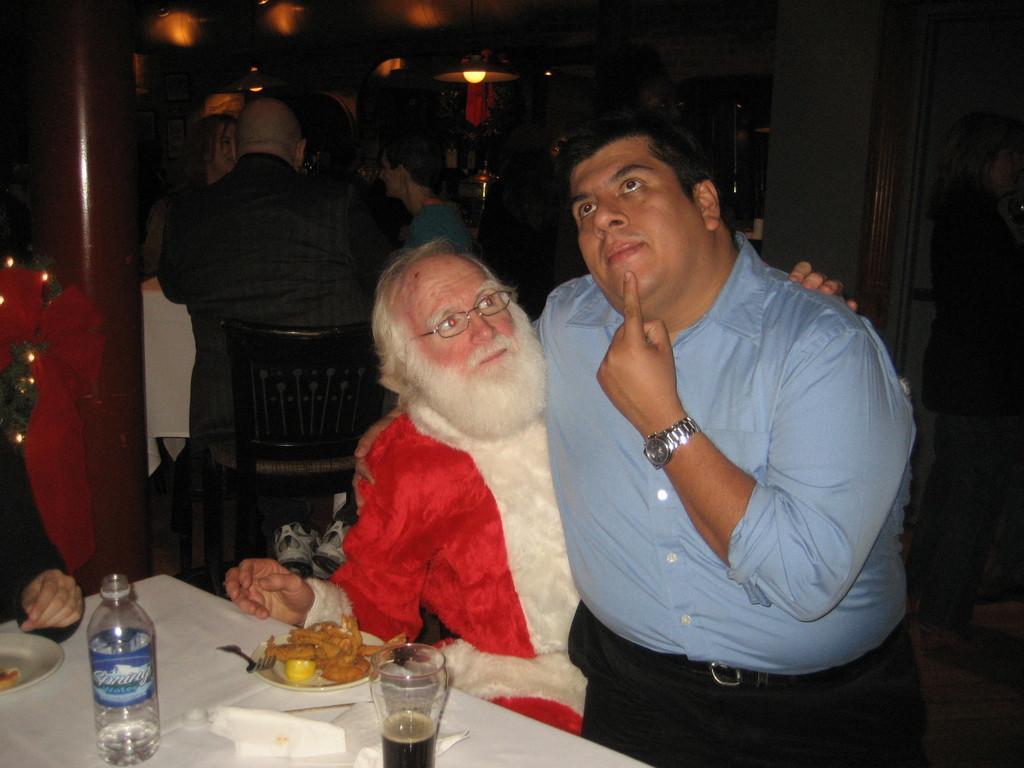How would you summarize this image in a sentence or two? In the foreground of this image, there is a man sitting on the another man who is sitting on the chair. There is a table in front of them on which bottle, platters, fork and glass are placed. In the background, there are persons sitting on the chairs near a table, a pillar, lights and the wall. 